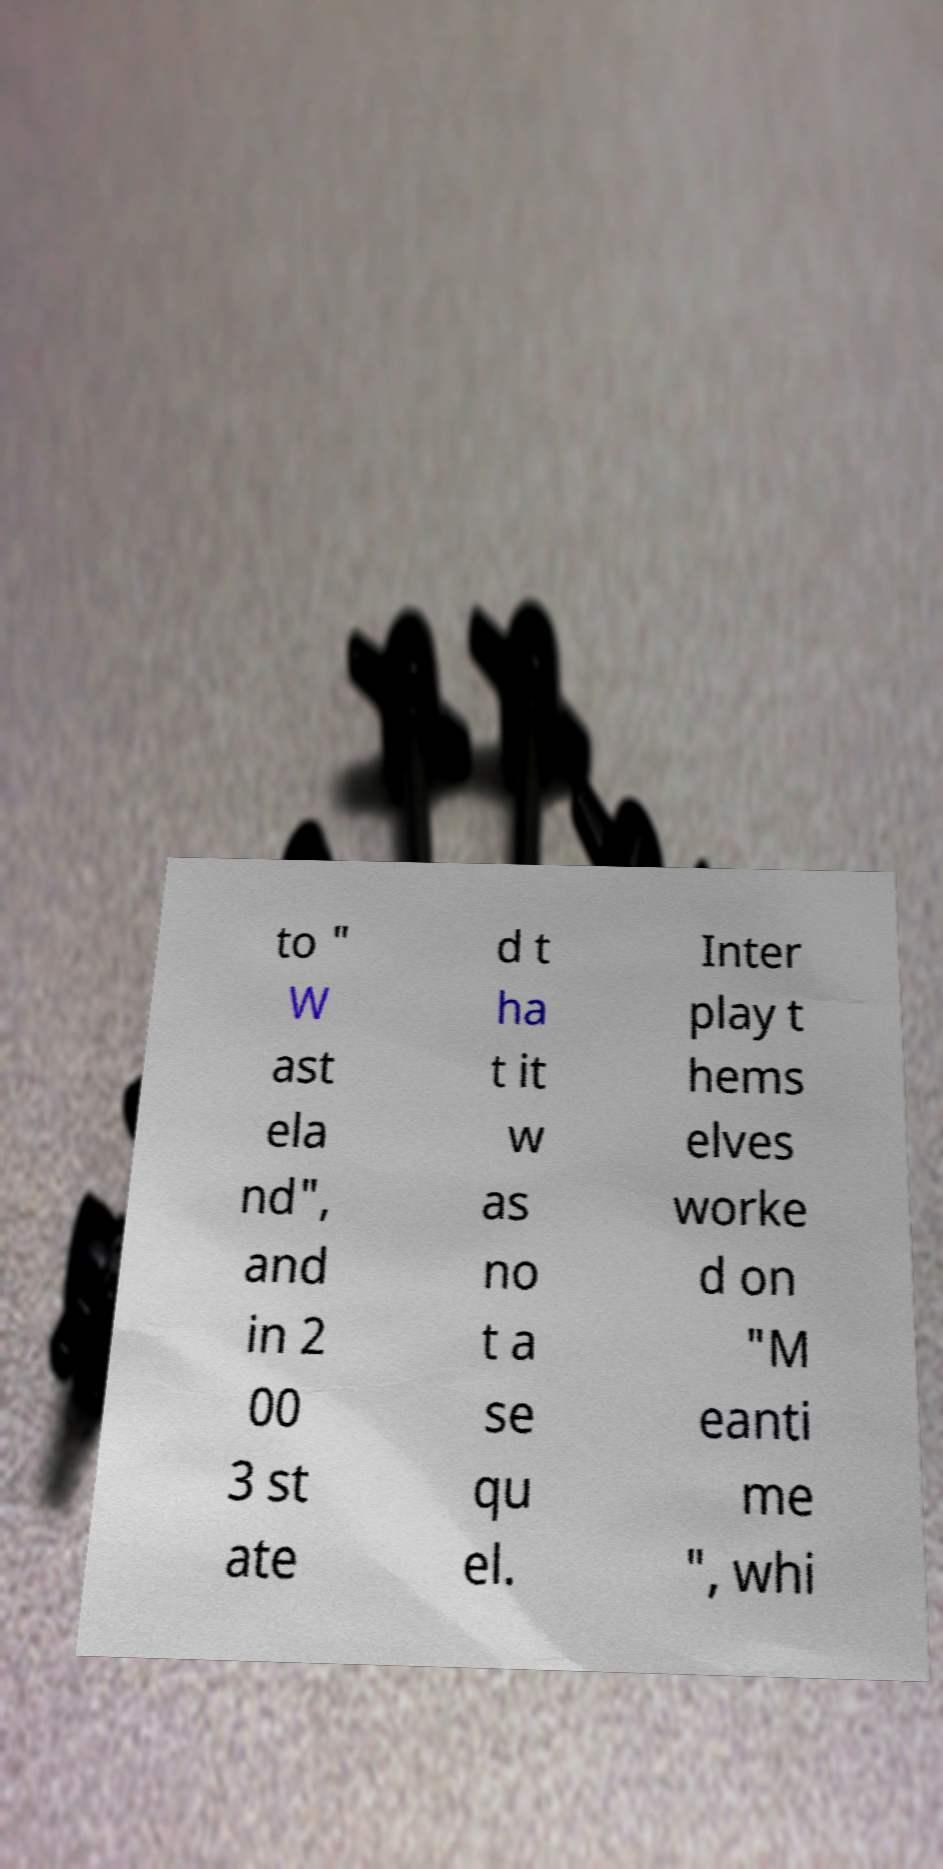Can you accurately transcribe the text from the provided image for me? to " W ast ela nd", and in 2 00 3 st ate d t ha t it w as no t a se qu el. Inter play t hems elves worke d on "M eanti me ", whi 